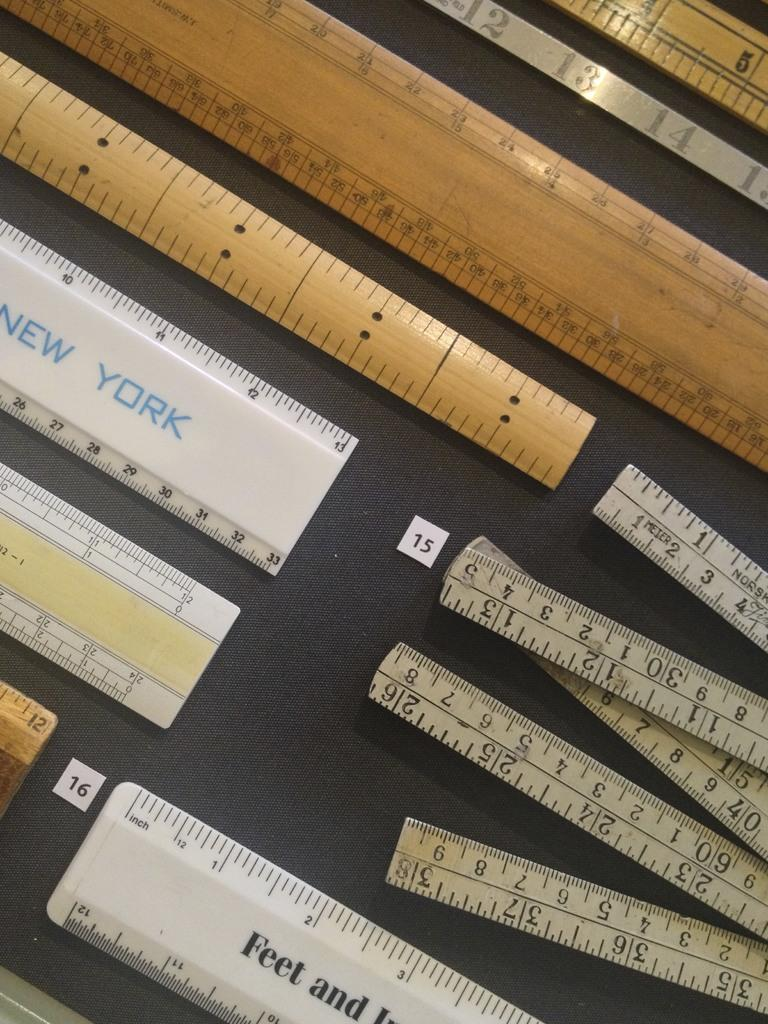Provide a one-sentence caption for the provided image. Messages on a collection of rulers include the words "Feet and" and "New York". 